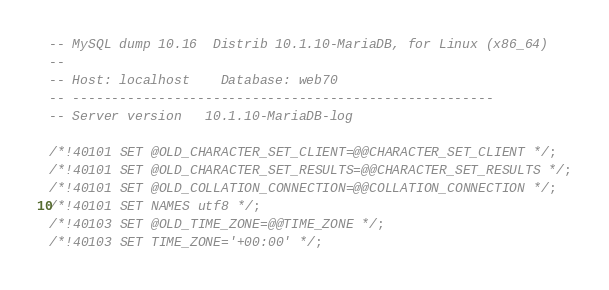Convert code to text. <code><loc_0><loc_0><loc_500><loc_500><_SQL_>-- MySQL dump 10.16  Distrib 10.1.10-MariaDB, for Linux (x86_64)
--
-- Host: localhost    Database: web70
-- ------------------------------------------------------
-- Server version	10.1.10-MariaDB-log

/*!40101 SET @OLD_CHARACTER_SET_CLIENT=@@CHARACTER_SET_CLIENT */;
/*!40101 SET @OLD_CHARACTER_SET_RESULTS=@@CHARACTER_SET_RESULTS */;
/*!40101 SET @OLD_COLLATION_CONNECTION=@@COLLATION_CONNECTION */;
/*!40101 SET NAMES utf8 */;
/*!40103 SET @OLD_TIME_ZONE=@@TIME_ZONE */;
/*!40103 SET TIME_ZONE='+00:00' */;</code> 